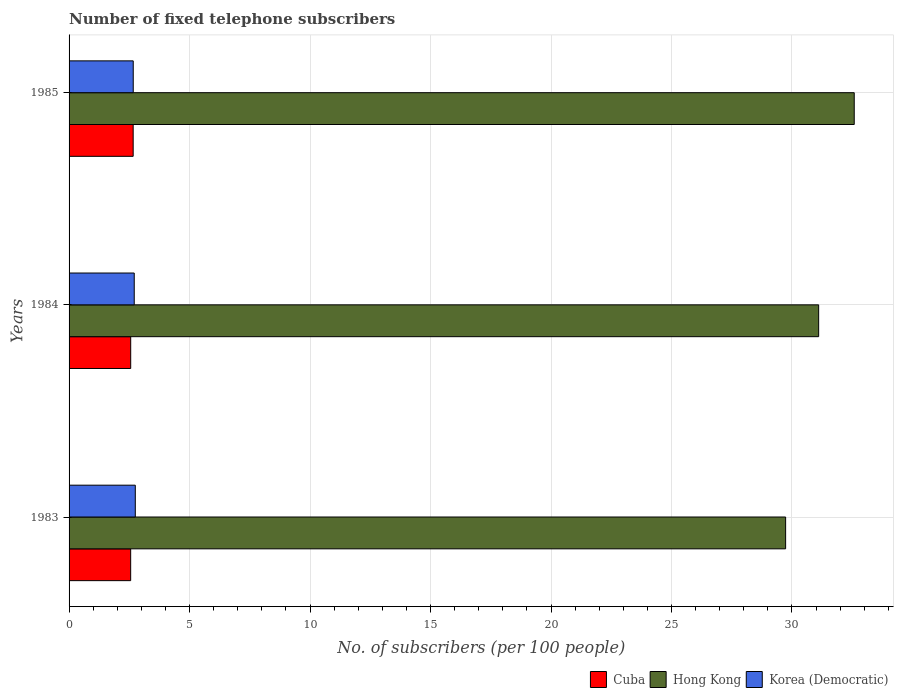How many different coloured bars are there?
Your answer should be compact. 3. How many groups of bars are there?
Make the answer very short. 3. How many bars are there on the 2nd tick from the bottom?
Make the answer very short. 3. What is the number of fixed telephone subscribers in Korea (Democratic) in 1985?
Your response must be concise. 2.66. Across all years, what is the maximum number of fixed telephone subscribers in Korea (Democratic)?
Offer a terse response. 2.75. Across all years, what is the minimum number of fixed telephone subscribers in Hong Kong?
Provide a succinct answer. 29.74. What is the total number of fixed telephone subscribers in Cuba in the graph?
Provide a short and direct response. 7.77. What is the difference between the number of fixed telephone subscribers in Cuba in 1984 and that in 1985?
Provide a short and direct response. -0.1. What is the difference between the number of fixed telephone subscribers in Korea (Democratic) in 1985 and the number of fixed telephone subscribers in Cuba in 1984?
Your answer should be compact. 0.1. What is the average number of fixed telephone subscribers in Cuba per year?
Offer a very short reply. 2.59. In the year 1985, what is the difference between the number of fixed telephone subscribers in Korea (Democratic) and number of fixed telephone subscribers in Hong Kong?
Provide a succinct answer. -29.92. In how many years, is the number of fixed telephone subscribers in Korea (Democratic) greater than 12 ?
Provide a succinct answer. 0. What is the ratio of the number of fixed telephone subscribers in Cuba in 1983 to that in 1985?
Your answer should be compact. 0.96. Is the difference between the number of fixed telephone subscribers in Korea (Democratic) in 1983 and 1985 greater than the difference between the number of fixed telephone subscribers in Hong Kong in 1983 and 1985?
Your response must be concise. Yes. What is the difference between the highest and the second highest number of fixed telephone subscribers in Hong Kong?
Provide a succinct answer. 1.48. What is the difference between the highest and the lowest number of fixed telephone subscribers in Cuba?
Keep it short and to the point. 0.1. What does the 3rd bar from the top in 1985 represents?
Provide a short and direct response. Cuba. What does the 2nd bar from the bottom in 1984 represents?
Your answer should be very brief. Hong Kong. How many bars are there?
Your answer should be very brief. 9. Are all the bars in the graph horizontal?
Your answer should be compact. Yes. What is the difference between two consecutive major ticks on the X-axis?
Your response must be concise. 5. Where does the legend appear in the graph?
Offer a very short reply. Bottom right. How are the legend labels stacked?
Give a very brief answer. Horizontal. What is the title of the graph?
Provide a succinct answer. Number of fixed telephone subscribers. What is the label or title of the X-axis?
Offer a terse response. No. of subscribers (per 100 people). What is the No. of subscribers (per 100 people) in Cuba in 1983?
Your response must be concise. 2.56. What is the No. of subscribers (per 100 people) in Hong Kong in 1983?
Provide a short and direct response. 29.74. What is the No. of subscribers (per 100 people) of Korea (Democratic) in 1983?
Offer a very short reply. 2.75. What is the No. of subscribers (per 100 people) of Cuba in 1984?
Provide a succinct answer. 2.56. What is the No. of subscribers (per 100 people) in Hong Kong in 1984?
Give a very brief answer. 31.11. What is the No. of subscribers (per 100 people) in Korea (Democratic) in 1984?
Make the answer very short. 2.7. What is the No. of subscribers (per 100 people) of Cuba in 1985?
Your answer should be very brief. 2.66. What is the No. of subscribers (per 100 people) of Hong Kong in 1985?
Offer a very short reply. 32.58. What is the No. of subscribers (per 100 people) of Korea (Democratic) in 1985?
Make the answer very short. 2.66. Across all years, what is the maximum No. of subscribers (per 100 people) of Cuba?
Offer a very short reply. 2.66. Across all years, what is the maximum No. of subscribers (per 100 people) in Hong Kong?
Offer a very short reply. 32.58. Across all years, what is the maximum No. of subscribers (per 100 people) in Korea (Democratic)?
Your answer should be very brief. 2.75. Across all years, what is the minimum No. of subscribers (per 100 people) in Cuba?
Your answer should be compact. 2.56. Across all years, what is the minimum No. of subscribers (per 100 people) in Hong Kong?
Offer a terse response. 29.74. Across all years, what is the minimum No. of subscribers (per 100 people) in Korea (Democratic)?
Provide a succinct answer. 2.66. What is the total No. of subscribers (per 100 people) of Cuba in the graph?
Make the answer very short. 7.77. What is the total No. of subscribers (per 100 people) in Hong Kong in the graph?
Your answer should be compact. 93.43. What is the total No. of subscribers (per 100 people) of Korea (Democratic) in the graph?
Make the answer very short. 8.12. What is the difference between the No. of subscribers (per 100 people) of Cuba in 1983 and that in 1984?
Ensure brevity in your answer.  -0. What is the difference between the No. of subscribers (per 100 people) in Hong Kong in 1983 and that in 1984?
Give a very brief answer. -1.37. What is the difference between the No. of subscribers (per 100 people) of Korea (Democratic) in 1983 and that in 1984?
Offer a terse response. 0.04. What is the difference between the No. of subscribers (per 100 people) of Cuba in 1983 and that in 1985?
Keep it short and to the point. -0.1. What is the difference between the No. of subscribers (per 100 people) of Hong Kong in 1983 and that in 1985?
Provide a succinct answer. -2.85. What is the difference between the No. of subscribers (per 100 people) in Korea (Democratic) in 1983 and that in 1985?
Your response must be concise. 0.09. What is the difference between the No. of subscribers (per 100 people) of Cuba in 1984 and that in 1985?
Offer a very short reply. -0.1. What is the difference between the No. of subscribers (per 100 people) of Hong Kong in 1984 and that in 1985?
Your response must be concise. -1.48. What is the difference between the No. of subscribers (per 100 people) of Korea (Democratic) in 1984 and that in 1985?
Provide a succinct answer. 0.04. What is the difference between the No. of subscribers (per 100 people) in Cuba in 1983 and the No. of subscribers (per 100 people) in Hong Kong in 1984?
Provide a short and direct response. -28.55. What is the difference between the No. of subscribers (per 100 people) of Cuba in 1983 and the No. of subscribers (per 100 people) of Korea (Democratic) in 1984?
Your response must be concise. -0.15. What is the difference between the No. of subscribers (per 100 people) in Hong Kong in 1983 and the No. of subscribers (per 100 people) in Korea (Democratic) in 1984?
Provide a succinct answer. 27.03. What is the difference between the No. of subscribers (per 100 people) in Cuba in 1983 and the No. of subscribers (per 100 people) in Hong Kong in 1985?
Offer a terse response. -30.03. What is the difference between the No. of subscribers (per 100 people) of Cuba in 1983 and the No. of subscribers (per 100 people) of Korea (Democratic) in 1985?
Offer a very short reply. -0.11. What is the difference between the No. of subscribers (per 100 people) of Hong Kong in 1983 and the No. of subscribers (per 100 people) of Korea (Democratic) in 1985?
Offer a terse response. 27.07. What is the difference between the No. of subscribers (per 100 people) of Cuba in 1984 and the No. of subscribers (per 100 people) of Hong Kong in 1985?
Provide a short and direct response. -30.03. What is the difference between the No. of subscribers (per 100 people) in Cuba in 1984 and the No. of subscribers (per 100 people) in Korea (Democratic) in 1985?
Provide a short and direct response. -0.1. What is the difference between the No. of subscribers (per 100 people) of Hong Kong in 1984 and the No. of subscribers (per 100 people) of Korea (Democratic) in 1985?
Give a very brief answer. 28.44. What is the average No. of subscribers (per 100 people) in Cuba per year?
Your response must be concise. 2.59. What is the average No. of subscribers (per 100 people) in Hong Kong per year?
Ensure brevity in your answer.  31.14. What is the average No. of subscribers (per 100 people) in Korea (Democratic) per year?
Your answer should be compact. 2.71. In the year 1983, what is the difference between the No. of subscribers (per 100 people) in Cuba and No. of subscribers (per 100 people) in Hong Kong?
Offer a very short reply. -27.18. In the year 1983, what is the difference between the No. of subscribers (per 100 people) of Cuba and No. of subscribers (per 100 people) of Korea (Democratic)?
Your response must be concise. -0.19. In the year 1983, what is the difference between the No. of subscribers (per 100 people) of Hong Kong and No. of subscribers (per 100 people) of Korea (Democratic)?
Your response must be concise. 26.99. In the year 1984, what is the difference between the No. of subscribers (per 100 people) of Cuba and No. of subscribers (per 100 people) of Hong Kong?
Keep it short and to the point. -28.55. In the year 1984, what is the difference between the No. of subscribers (per 100 people) of Cuba and No. of subscribers (per 100 people) of Korea (Democratic)?
Your answer should be very brief. -0.15. In the year 1984, what is the difference between the No. of subscribers (per 100 people) of Hong Kong and No. of subscribers (per 100 people) of Korea (Democratic)?
Your response must be concise. 28.4. In the year 1985, what is the difference between the No. of subscribers (per 100 people) in Cuba and No. of subscribers (per 100 people) in Hong Kong?
Make the answer very short. -29.92. In the year 1985, what is the difference between the No. of subscribers (per 100 people) in Cuba and No. of subscribers (per 100 people) in Korea (Democratic)?
Give a very brief answer. -0. In the year 1985, what is the difference between the No. of subscribers (per 100 people) in Hong Kong and No. of subscribers (per 100 people) in Korea (Democratic)?
Your response must be concise. 29.92. What is the ratio of the No. of subscribers (per 100 people) of Hong Kong in 1983 to that in 1984?
Give a very brief answer. 0.96. What is the ratio of the No. of subscribers (per 100 people) of Korea (Democratic) in 1983 to that in 1984?
Your answer should be very brief. 1.02. What is the ratio of the No. of subscribers (per 100 people) in Hong Kong in 1983 to that in 1985?
Offer a terse response. 0.91. What is the ratio of the No. of subscribers (per 100 people) of Korea (Democratic) in 1983 to that in 1985?
Give a very brief answer. 1.03. What is the ratio of the No. of subscribers (per 100 people) in Cuba in 1984 to that in 1985?
Your answer should be compact. 0.96. What is the ratio of the No. of subscribers (per 100 people) in Hong Kong in 1984 to that in 1985?
Provide a short and direct response. 0.95. What is the ratio of the No. of subscribers (per 100 people) in Korea (Democratic) in 1984 to that in 1985?
Provide a short and direct response. 1.02. What is the difference between the highest and the second highest No. of subscribers (per 100 people) in Cuba?
Ensure brevity in your answer.  0.1. What is the difference between the highest and the second highest No. of subscribers (per 100 people) in Hong Kong?
Keep it short and to the point. 1.48. What is the difference between the highest and the second highest No. of subscribers (per 100 people) in Korea (Democratic)?
Your response must be concise. 0.04. What is the difference between the highest and the lowest No. of subscribers (per 100 people) in Cuba?
Provide a short and direct response. 0.1. What is the difference between the highest and the lowest No. of subscribers (per 100 people) of Hong Kong?
Give a very brief answer. 2.85. What is the difference between the highest and the lowest No. of subscribers (per 100 people) of Korea (Democratic)?
Make the answer very short. 0.09. 